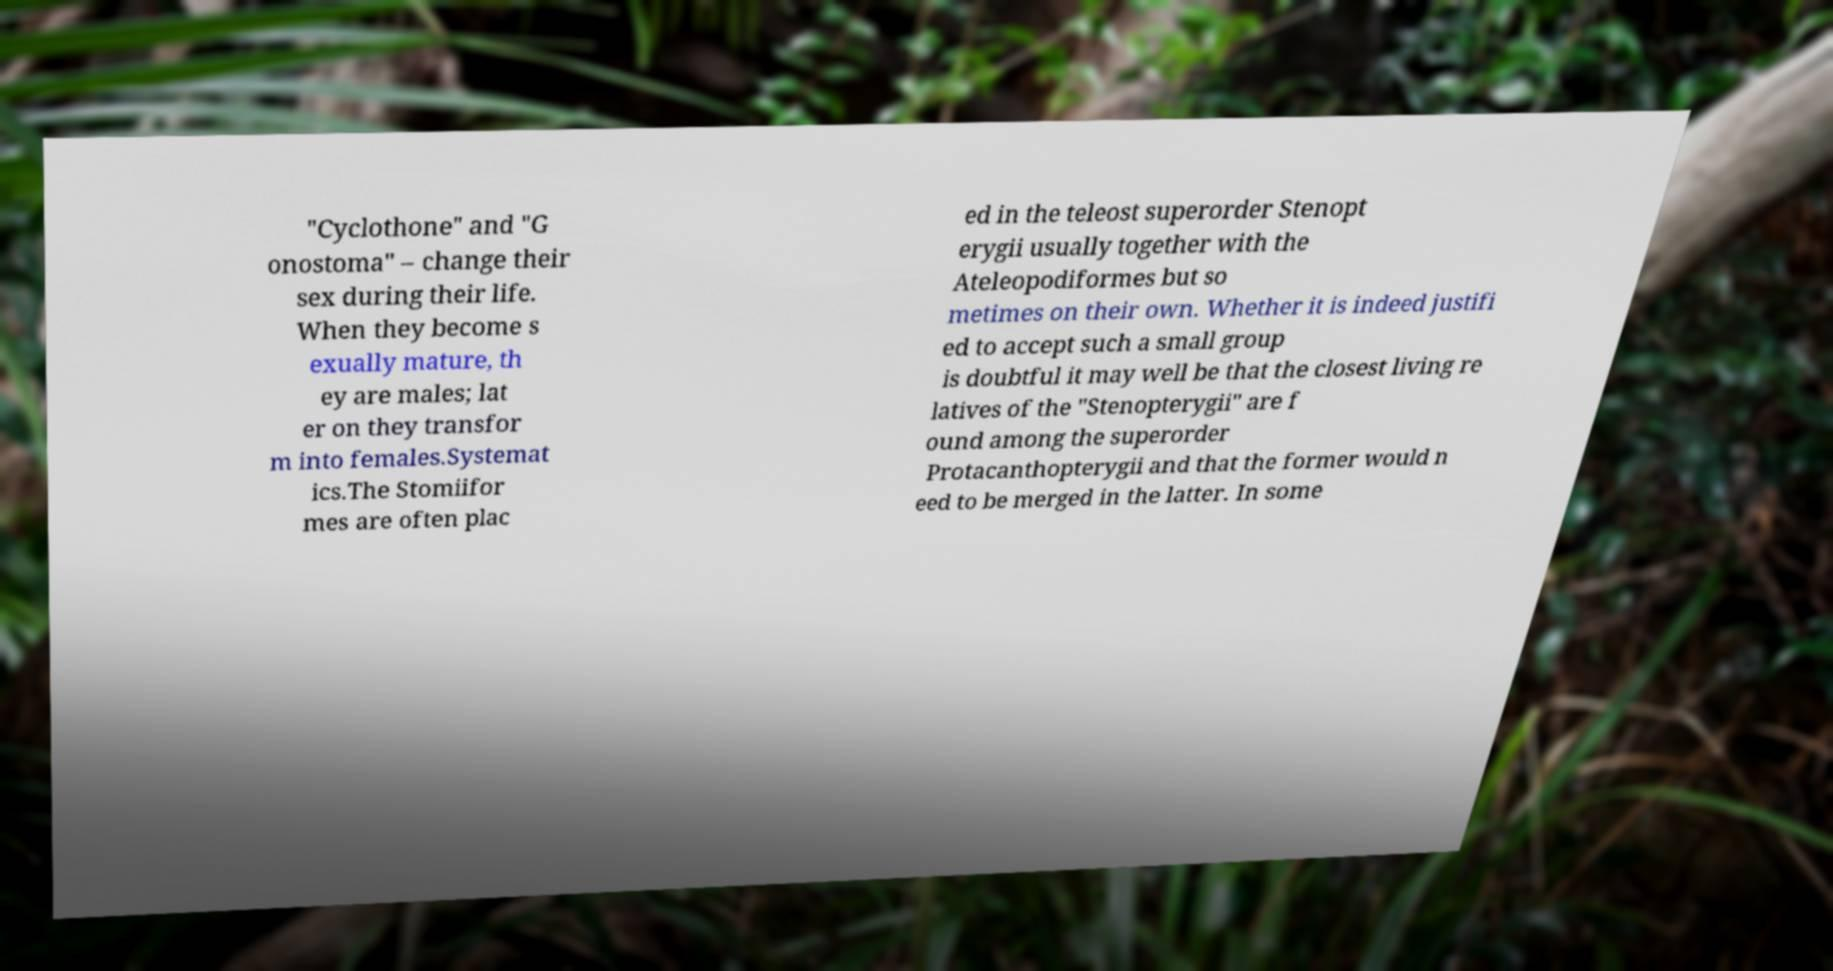Please read and relay the text visible in this image. What does it say? "Cyclothone" and "G onostoma" – change their sex during their life. When they become s exually mature, th ey are males; lat er on they transfor m into females.Systemat ics.The Stomiifor mes are often plac ed in the teleost superorder Stenopt erygii usually together with the Ateleopodiformes but so metimes on their own. Whether it is indeed justifi ed to accept such a small group is doubtful it may well be that the closest living re latives of the "Stenopterygii" are f ound among the superorder Protacanthopterygii and that the former would n eed to be merged in the latter. In some 